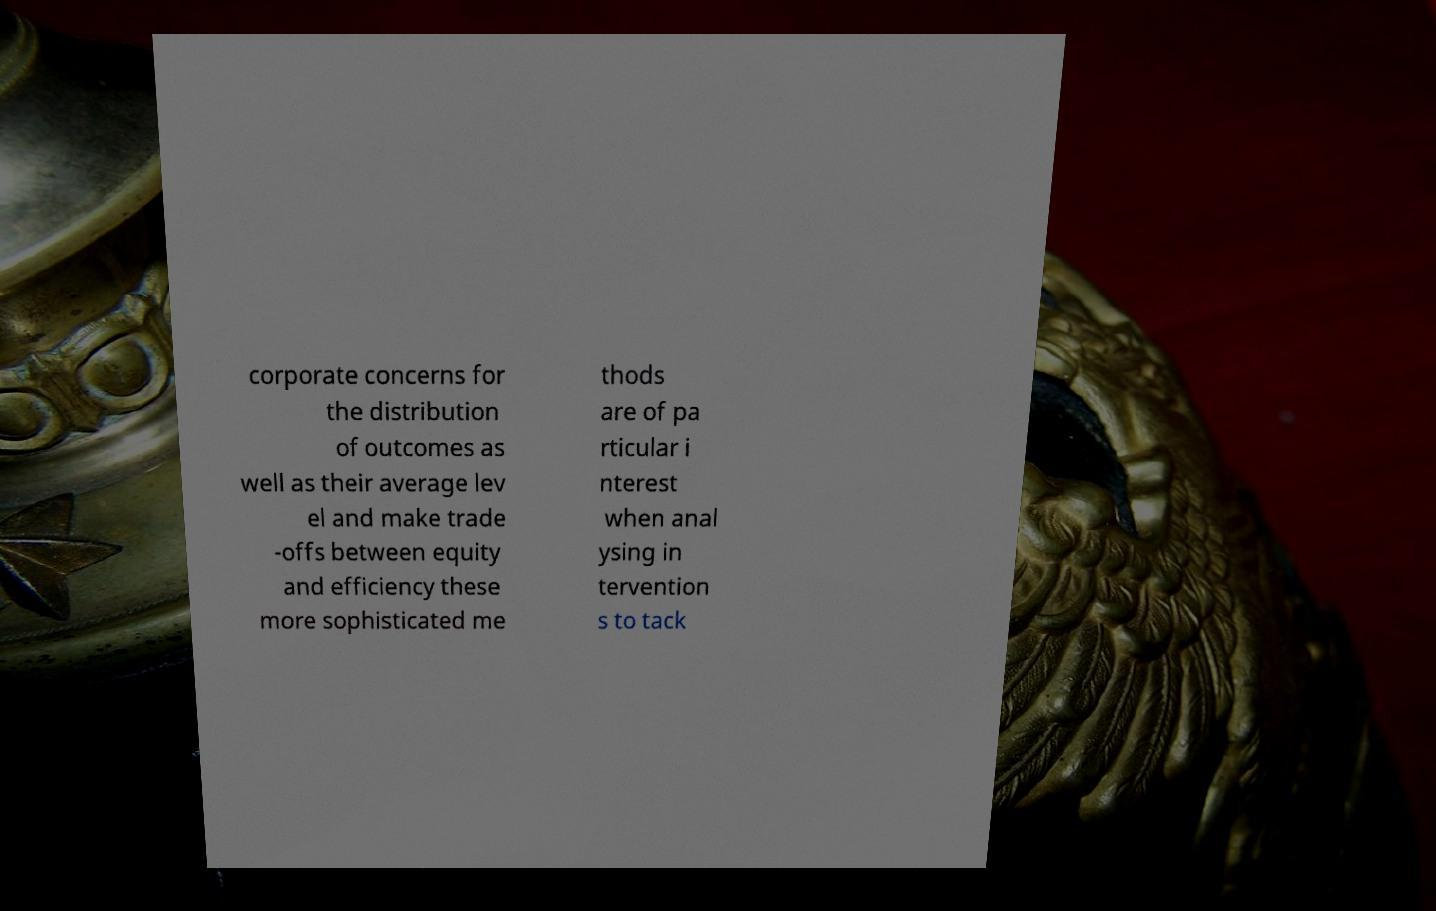Could you extract and type out the text from this image? corporate concerns for the distribution of outcomes as well as their average lev el and make trade -offs between equity and efficiency these more sophisticated me thods are of pa rticular i nterest when anal ysing in tervention s to tack 